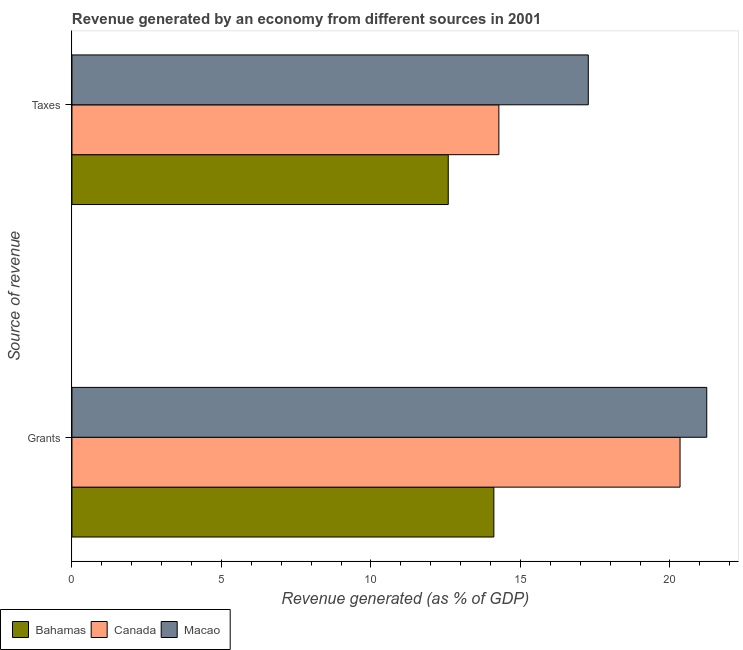Are the number of bars per tick equal to the number of legend labels?
Offer a very short reply. Yes. How many bars are there on the 1st tick from the bottom?
Give a very brief answer. 3. What is the label of the 1st group of bars from the top?
Make the answer very short. Taxes. What is the revenue generated by taxes in Bahamas?
Provide a short and direct response. 12.58. Across all countries, what is the maximum revenue generated by taxes?
Your answer should be very brief. 17.27. Across all countries, what is the minimum revenue generated by grants?
Offer a very short reply. 14.11. In which country was the revenue generated by grants maximum?
Make the answer very short. Macao. In which country was the revenue generated by taxes minimum?
Provide a short and direct response. Bahamas. What is the total revenue generated by grants in the graph?
Your answer should be very brief. 55.68. What is the difference between the revenue generated by grants in Macao and that in Canada?
Ensure brevity in your answer.  0.89. What is the difference between the revenue generated by taxes in Macao and the revenue generated by grants in Bahamas?
Offer a very short reply. 3.16. What is the average revenue generated by grants per country?
Make the answer very short. 18.56. What is the difference between the revenue generated by grants and revenue generated by taxes in Macao?
Keep it short and to the point. 3.96. In how many countries, is the revenue generated by taxes greater than 15 %?
Your answer should be compact. 1. What is the ratio of the revenue generated by taxes in Bahamas to that in Canada?
Your answer should be compact. 0.88. What does the 1st bar from the top in Taxes represents?
Keep it short and to the point. Macao. What does the 1st bar from the bottom in Grants represents?
Make the answer very short. Bahamas. Are all the bars in the graph horizontal?
Your response must be concise. Yes. Are the values on the major ticks of X-axis written in scientific E-notation?
Offer a terse response. No. Does the graph contain grids?
Keep it short and to the point. No. Where does the legend appear in the graph?
Provide a short and direct response. Bottom left. How many legend labels are there?
Keep it short and to the point. 3. How are the legend labels stacked?
Give a very brief answer. Horizontal. What is the title of the graph?
Offer a terse response. Revenue generated by an economy from different sources in 2001. What is the label or title of the X-axis?
Your answer should be very brief. Revenue generated (as % of GDP). What is the label or title of the Y-axis?
Make the answer very short. Source of revenue. What is the Revenue generated (as % of GDP) of Bahamas in Grants?
Your answer should be compact. 14.11. What is the Revenue generated (as % of GDP) in Canada in Grants?
Offer a terse response. 20.34. What is the Revenue generated (as % of GDP) in Macao in Grants?
Your answer should be compact. 21.23. What is the Revenue generated (as % of GDP) of Bahamas in Taxes?
Offer a very short reply. 12.58. What is the Revenue generated (as % of GDP) in Canada in Taxes?
Your response must be concise. 14.28. What is the Revenue generated (as % of GDP) in Macao in Taxes?
Make the answer very short. 17.27. Across all Source of revenue, what is the maximum Revenue generated (as % of GDP) in Bahamas?
Ensure brevity in your answer.  14.11. Across all Source of revenue, what is the maximum Revenue generated (as % of GDP) of Canada?
Give a very brief answer. 20.34. Across all Source of revenue, what is the maximum Revenue generated (as % of GDP) in Macao?
Your answer should be very brief. 21.23. Across all Source of revenue, what is the minimum Revenue generated (as % of GDP) of Bahamas?
Offer a terse response. 12.58. Across all Source of revenue, what is the minimum Revenue generated (as % of GDP) in Canada?
Offer a very short reply. 14.28. Across all Source of revenue, what is the minimum Revenue generated (as % of GDP) of Macao?
Offer a very short reply. 17.27. What is the total Revenue generated (as % of GDP) of Bahamas in the graph?
Give a very brief answer. 26.69. What is the total Revenue generated (as % of GDP) of Canada in the graph?
Give a very brief answer. 34.61. What is the total Revenue generated (as % of GDP) of Macao in the graph?
Keep it short and to the point. 38.5. What is the difference between the Revenue generated (as % of GDP) in Bahamas in Grants and that in Taxes?
Offer a very short reply. 1.53. What is the difference between the Revenue generated (as % of GDP) of Canada in Grants and that in Taxes?
Keep it short and to the point. 6.06. What is the difference between the Revenue generated (as % of GDP) of Macao in Grants and that in Taxes?
Make the answer very short. 3.96. What is the difference between the Revenue generated (as % of GDP) of Bahamas in Grants and the Revenue generated (as % of GDP) of Canada in Taxes?
Your answer should be very brief. -0.17. What is the difference between the Revenue generated (as % of GDP) of Bahamas in Grants and the Revenue generated (as % of GDP) of Macao in Taxes?
Your response must be concise. -3.16. What is the difference between the Revenue generated (as % of GDP) of Canada in Grants and the Revenue generated (as % of GDP) of Macao in Taxes?
Your response must be concise. 3.07. What is the average Revenue generated (as % of GDP) of Bahamas per Source of revenue?
Provide a succinct answer. 13.35. What is the average Revenue generated (as % of GDP) of Canada per Source of revenue?
Ensure brevity in your answer.  17.31. What is the average Revenue generated (as % of GDP) in Macao per Source of revenue?
Provide a succinct answer. 19.25. What is the difference between the Revenue generated (as % of GDP) of Bahamas and Revenue generated (as % of GDP) of Canada in Grants?
Your response must be concise. -6.23. What is the difference between the Revenue generated (as % of GDP) of Bahamas and Revenue generated (as % of GDP) of Macao in Grants?
Your response must be concise. -7.12. What is the difference between the Revenue generated (as % of GDP) in Canada and Revenue generated (as % of GDP) in Macao in Grants?
Keep it short and to the point. -0.89. What is the difference between the Revenue generated (as % of GDP) of Bahamas and Revenue generated (as % of GDP) of Canada in Taxes?
Your response must be concise. -1.69. What is the difference between the Revenue generated (as % of GDP) in Bahamas and Revenue generated (as % of GDP) in Macao in Taxes?
Your response must be concise. -4.68. What is the difference between the Revenue generated (as % of GDP) of Canada and Revenue generated (as % of GDP) of Macao in Taxes?
Provide a succinct answer. -2.99. What is the ratio of the Revenue generated (as % of GDP) in Bahamas in Grants to that in Taxes?
Ensure brevity in your answer.  1.12. What is the ratio of the Revenue generated (as % of GDP) of Canada in Grants to that in Taxes?
Your answer should be compact. 1.42. What is the ratio of the Revenue generated (as % of GDP) in Macao in Grants to that in Taxes?
Provide a succinct answer. 1.23. What is the difference between the highest and the second highest Revenue generated (as % of GDP) in Bahamas?
Give a very brief answer. 1.53. What is the difference between the highest and the second highest Revenue generated (as % of GDP) in Canada?
Give a very brief answer. 6.06. What is the difference between the highest and the second highest Revenue generated (as % of GDP) of Macao?
Your answer should be very brief. 3.96. What is the difference between the highest and the lowest Revenue generated (as % of GDP) in Bahamas?
Ensure brevity in your answer.  1.53. What is the difference between the highest and the lowest Revenue generated (as % of GDP) of Canada?
Keep it short and to the point. 6.06. What is the difference between the highest and the lowest Revenue generated (as % of GDP) of Macao?
Ensure brevity in your answer.  3.96. 